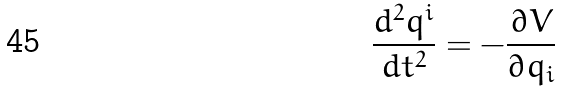<formula> <loc_0><loc_0><loc_500><loc_500>\frac { d ^ { 2 } q ^ { i } } { d t ^ { 2 } } = - \frac { \partial V } { \partial q _ { i } }</formula> 